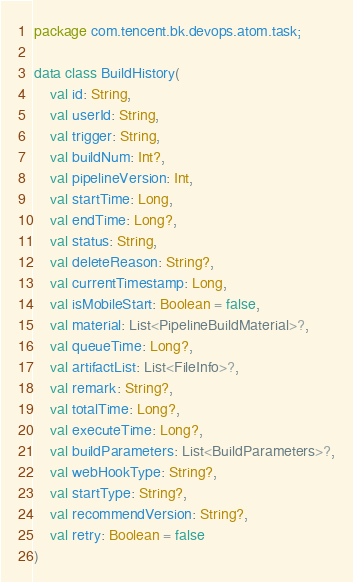<code> <loc_0><loc_0><loc_500><loc_500><_Kotlin_>package com.tencent.bk.devops.atom.task;

data class BuildHistory(
    val id: String,
    val userId: String,
    val trigger: String,
    val buildNum: Int?,
    val pipelineVersion: Int,
    val startTime: Long,
    val endTime: Long?,
    val status: String,
    val deleteReason: String?,
    val currentTimestamp: Long,
    val isMobileStart: Boolean = false,
    val material: List<PipelineBuildMaterial>?,
    val queueTime: Long?,
    val artifactList: List<FileInfo>?,
    val remark: String?,
    val totalTime: Long?,
    val executeTime: Long?,
    val buildParameters: List<BuildParameters>?,
    val webHookType: String?,
    val startType: String?,
    val recommendVersion: String?,
    val retry: Boolean = false
)</code> 